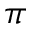Convert formula to latex. <formula><loc_0><loc_0><loc_500><loc_500>\pi</formula> 